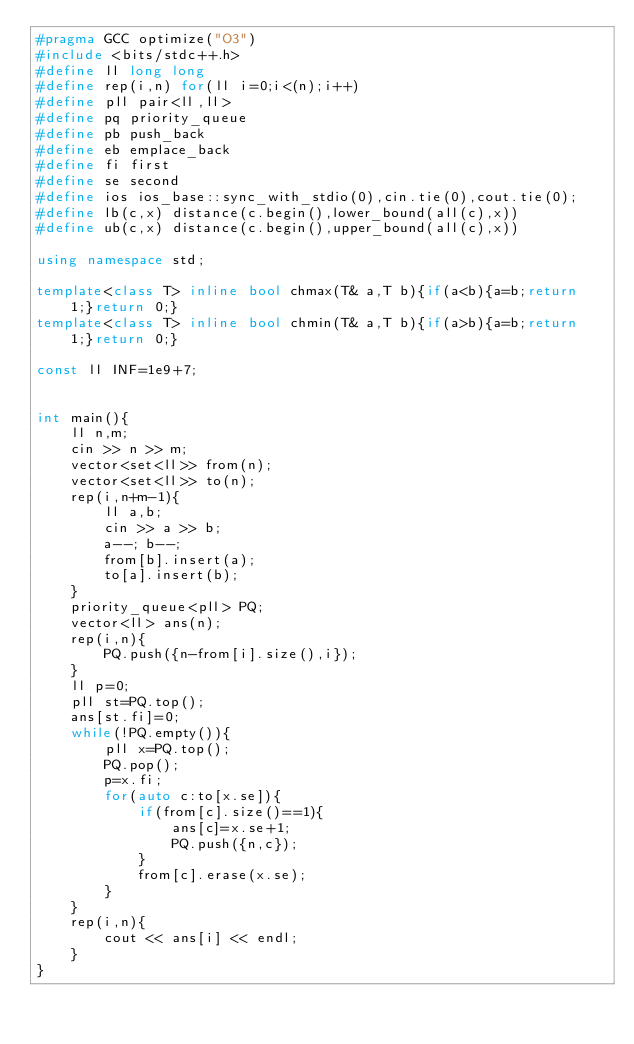Convert code to text. <code><loc_0><loc_0><loc_500><loc_500><_C++_>#pragma GCC optimize("O3")
#include <bits/stdc++.h>
#define ll long long
#define rep(i,n) for(ll i=0;i<(n);i++)
#define pll pair<ll,ll>
#define pq priority_queue
#define pb push_back
#define eb emplace_back
#define fi first
#define se second
#define ios ios_base::sync_with_stdio(0),cin.tie(0),cout.tie(0);
#define lb(c,x) distance(c.begin(),lower_bound(all(c),x))
#define ub(c,x) distance(c.begin(),upper_bound(all(c),x))

using namespace std;

template<class T> inline bool chmax(T& a,T b){if(a<b){a=b;return 1;}return 0;}
template<class T> inline bool chmin(T& a,T b){if(a>b){a=b;return 1;}return 0;}

const ll INF=1e9+7;


int main(){
    ll n,m;
    cin >> n >> m;
    vector<set<ll>> from(n);
    vector<set<ll>> to(n);
    rep(i,n+m-1){
        ll a,b;
        cin >> a >> b;
        a--; b--;
        from[b].insert(a);
        to[a].insert(b);
    }
    priority_queue<pll> PQ;
    vector<ll> ans(n);
    rep(i,n){
        PQ.push({n-from[i].size(),i});
    }
    ll p=0;
    pll st=PQ.top();
    ans[st.fi]=0;
    while(!PQ.empty()){
        pll x=PQ.top();
        PQ.pop();
        p=x.fi;
        for(auto c:to[x.se]){
            if(from[c].size()==1){
                ans[c]=x.se+1;
                PQ.push({n,c});
            }
            from[c].erase(x.se);
        }
    }
    rep(i,n){
        cout << ans[i] << endl;
    }
}

</code> 